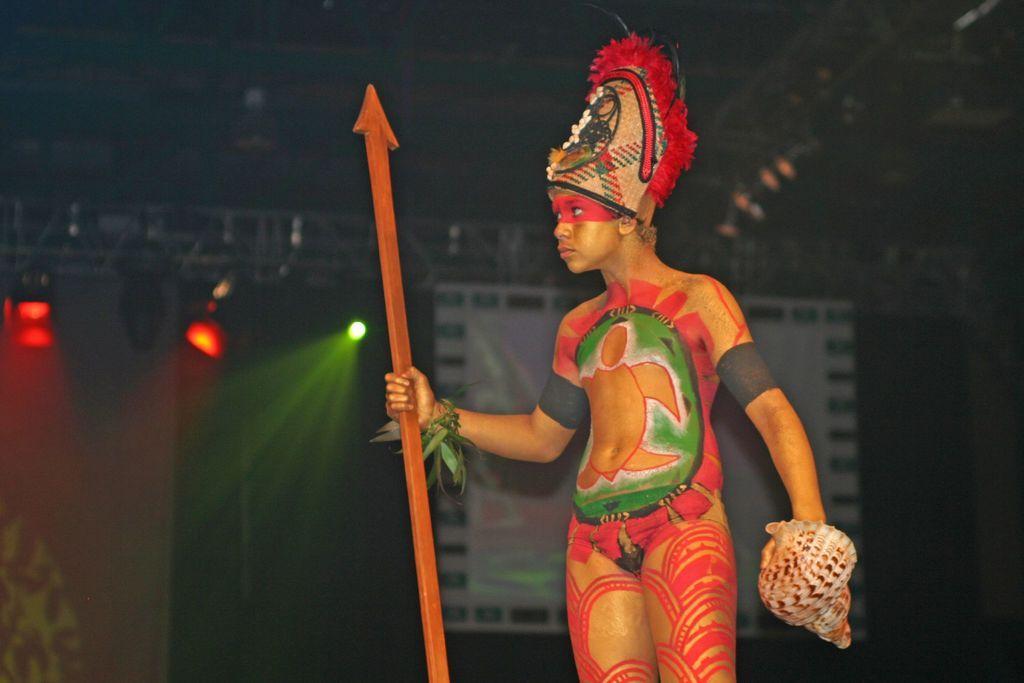Please provide a concise description of this image. In this image in the foreground we see a boy holding a stick and also some kind of instrument. 